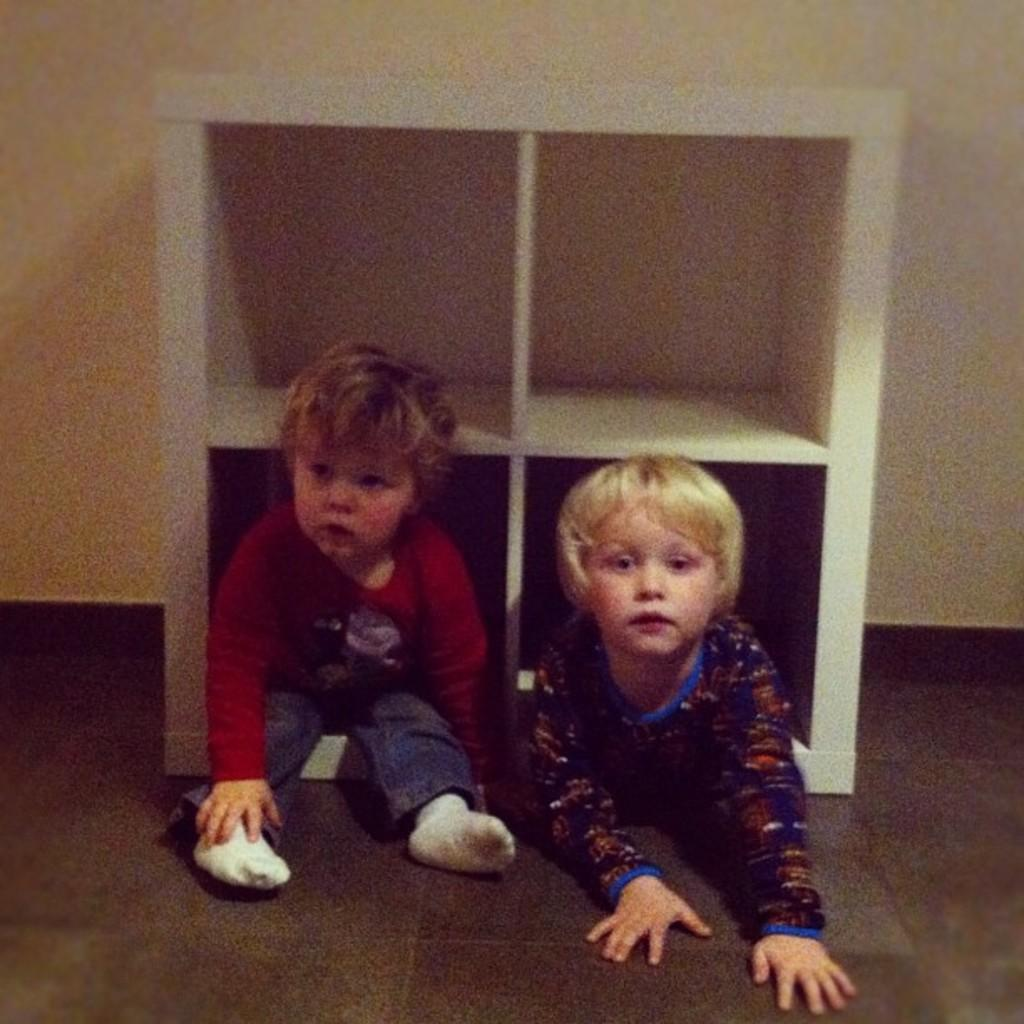How many children are in the image? There are two children in the image. Where are the children located in the image? The children are on the floor. What can be seen in the background of the image? There is a wooden rack visible in the image. What type of servant is attending to the children in the image? There is no servant present in the image; it only features two children on the floor and a wooden rack in the background. 